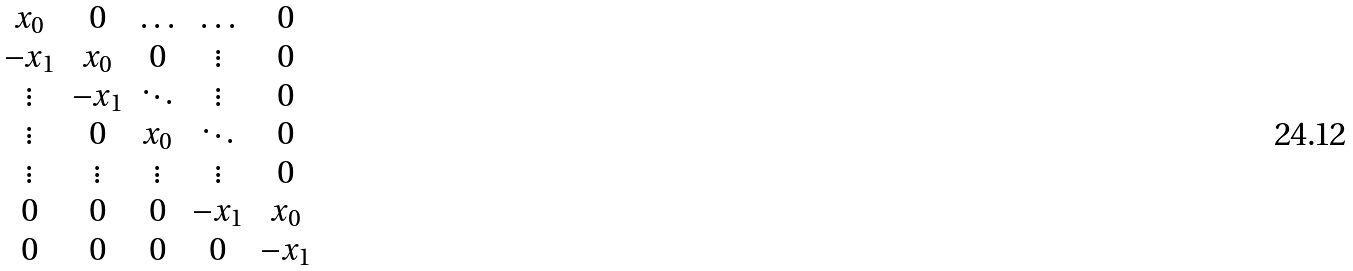<formula> <loc_0><loc_0><loc_500><loc_500>\begin{matrix} x _ { 0 } & 0 & \hdots & \hdots & 0 \\ - x _ { 1 } & x _ { 0 } & 0 & \vdots & 0 \\ \vdots & - x _ { 1 } & \ddots & \vdots & 0 \\ \vdots & 0 & x _ { 0 } & \ddots & 0 \\ \vdots & \vdots & \vdots & \vdots & 0 \\ 0 & 0 & 0 & - x _ { 1 } & x _ { 0 } \\ 0 & 0 & 0 & 0 & - x _ { 1 } \end{matrix}</formula> 